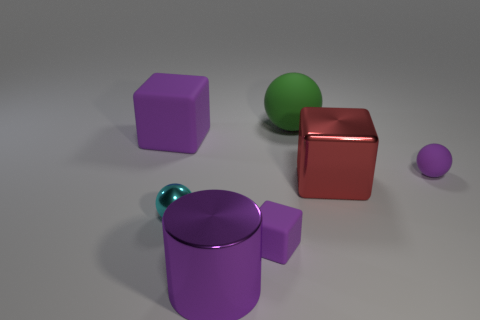Are there any other things that are the same shape as the large purple shiny thing?
Give a very brief answer. No. What is the color of the large object that is on the left side of the large purple object that is in front of the red metal block?
Provide a short and direct response. Purple. Is the number of red cubes greater than the number of gray spheres?
Your response must be concise. Yes. How many green matte spheres are the same size as the shiny block?
Give a very brief answer. 1. Is the large purple cube made of the same material as the small ball that is on the right side of the small purple block?
Make the answer very short. Yes. Are there fewer metallic blocks than metallic objects?
Provide a short and direct response. Yes. Is there any other thing that has the same color as the large shiny cylinder?
Provide a succinct answer. Yes. What shape is the tiny cyan thing that is the same material as the big cylinder?
Provide a succinct answer. Sphere. There is a large rubber object in front of the matte sphere that is left of the small purple sphere; how many cubes are right of it?
Your answer should be compact. 2. What shape is the large thing that is both behind the red metallic cube and in front of the green matte thing?
Give a very brief answer. Cube. 